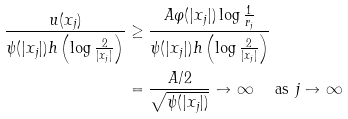Convert formula to latex. <formula><loc_0><loc_0><loc_500><loc_500>\frac { u ( x _ { j } ) } { \psi ( | x _ { j } | ) h \left ( \log \frac { 2 } { | x _ { j } | } \right ) } & \geq \frac { A \varphi ( | x _ { j } | ) \log \frac { 1 } { r _ { j } } } { \psi ( | x _ { j } | ) h \left ( \log \frac { 2 } { | x _ { j } | } \right ) } \\ & = \frac { A / 2 } { \sqrt { \psi ( | x _ { j } | ) } } \to \infty \quad \text { as } j \to \infty</formula> 